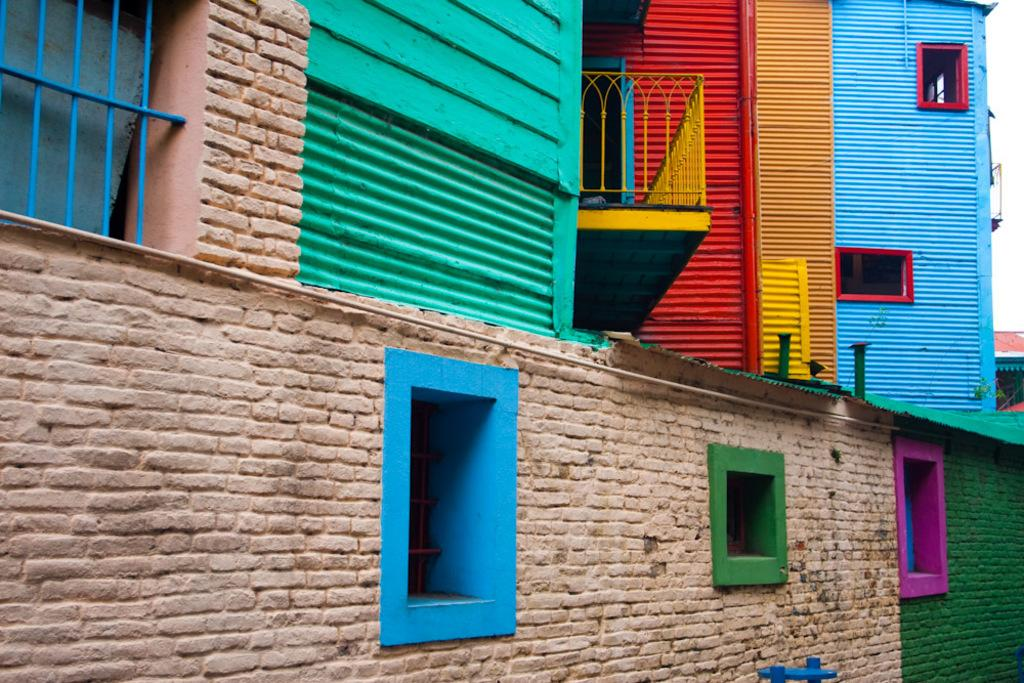What type of structure is in the image? There is a colorful building in the image. What architectural feature can be seen on the building? There are windows on the building. What is the reaction of the building when it hears a loud noise? Buildings do not have the ability to react or hear, so this question cannot be answered definitively from the image. 